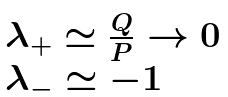Convert formula to latex. <formula><loc_0><loc_0><loc_500><loc_500>\begin{array} { l } \lambda _ { + } \simeq \frac { Q } { P } \rightarrow 0 \\ \lambda _ { - } \simeq - 1 \end{array}</formula> 